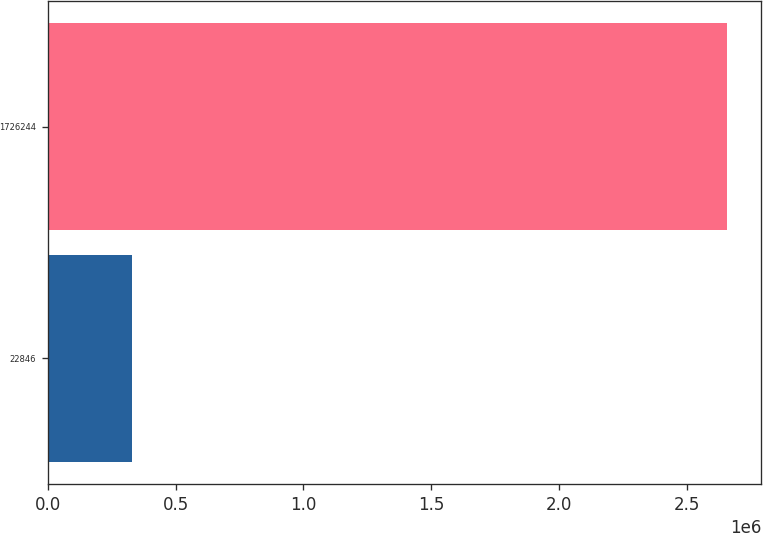Convert chart to OTSL. <chart><loc_0><loc_0><loc_500><loc_500><bar_chart><fcel>22846<fcel>1726244<nl><fcel>329944<fcel>2.65734e+06<nl></chart> 